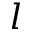<formula> <loc_0><loc_0><loc_500><loc_500>l</formula> 